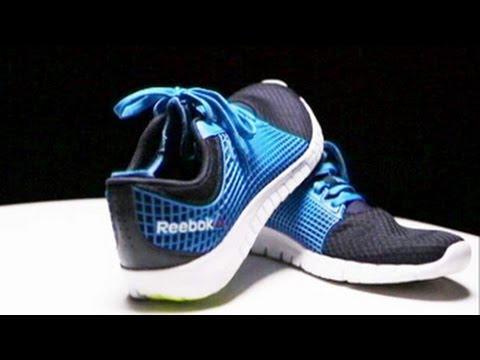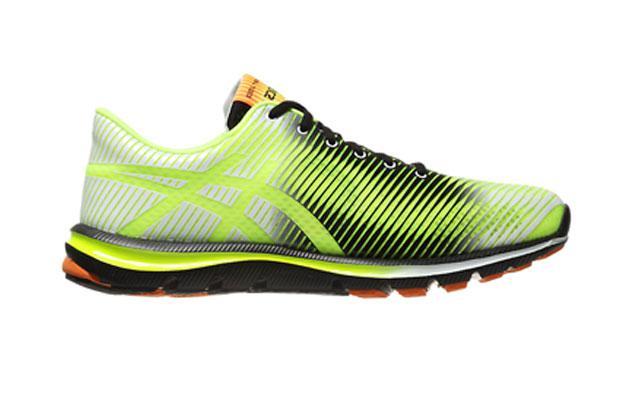The first image is the image on the left, the second image is the image on the right. Given the left and right images, does the statement "There is exactly three tennis shoes." hold true? Answer yes or no. Yes. The first image is the image on the left, the second image is the image on the right. Given the left and right images, does the statement "The left image shows a pair of sneakers with one of the sneakers resting partially atop the other" hold true? Answer yes or no. Yes. 